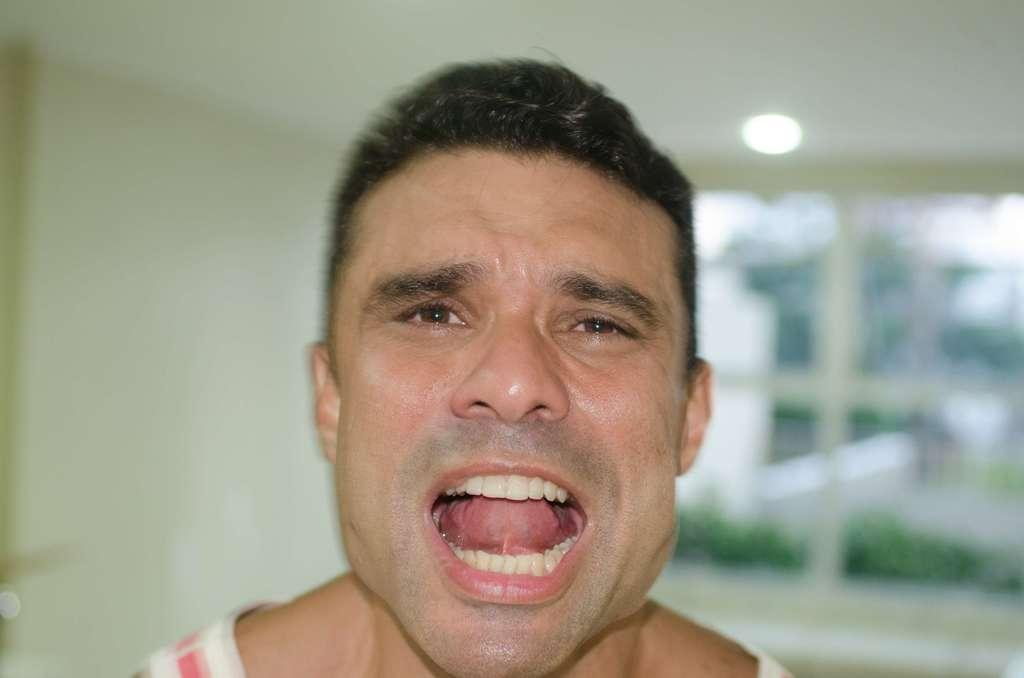Who is present in the image? There is a man in the image. What can be seen in the background of the image? There is a light in the background of the image. Where are the dolls playing around the volcano in the image? There are no dolls or volcanoes present in the image. What type of sponge is being used to clean the man's clothes in the image? There is no sponge or cleaning activity depicted in the image. 